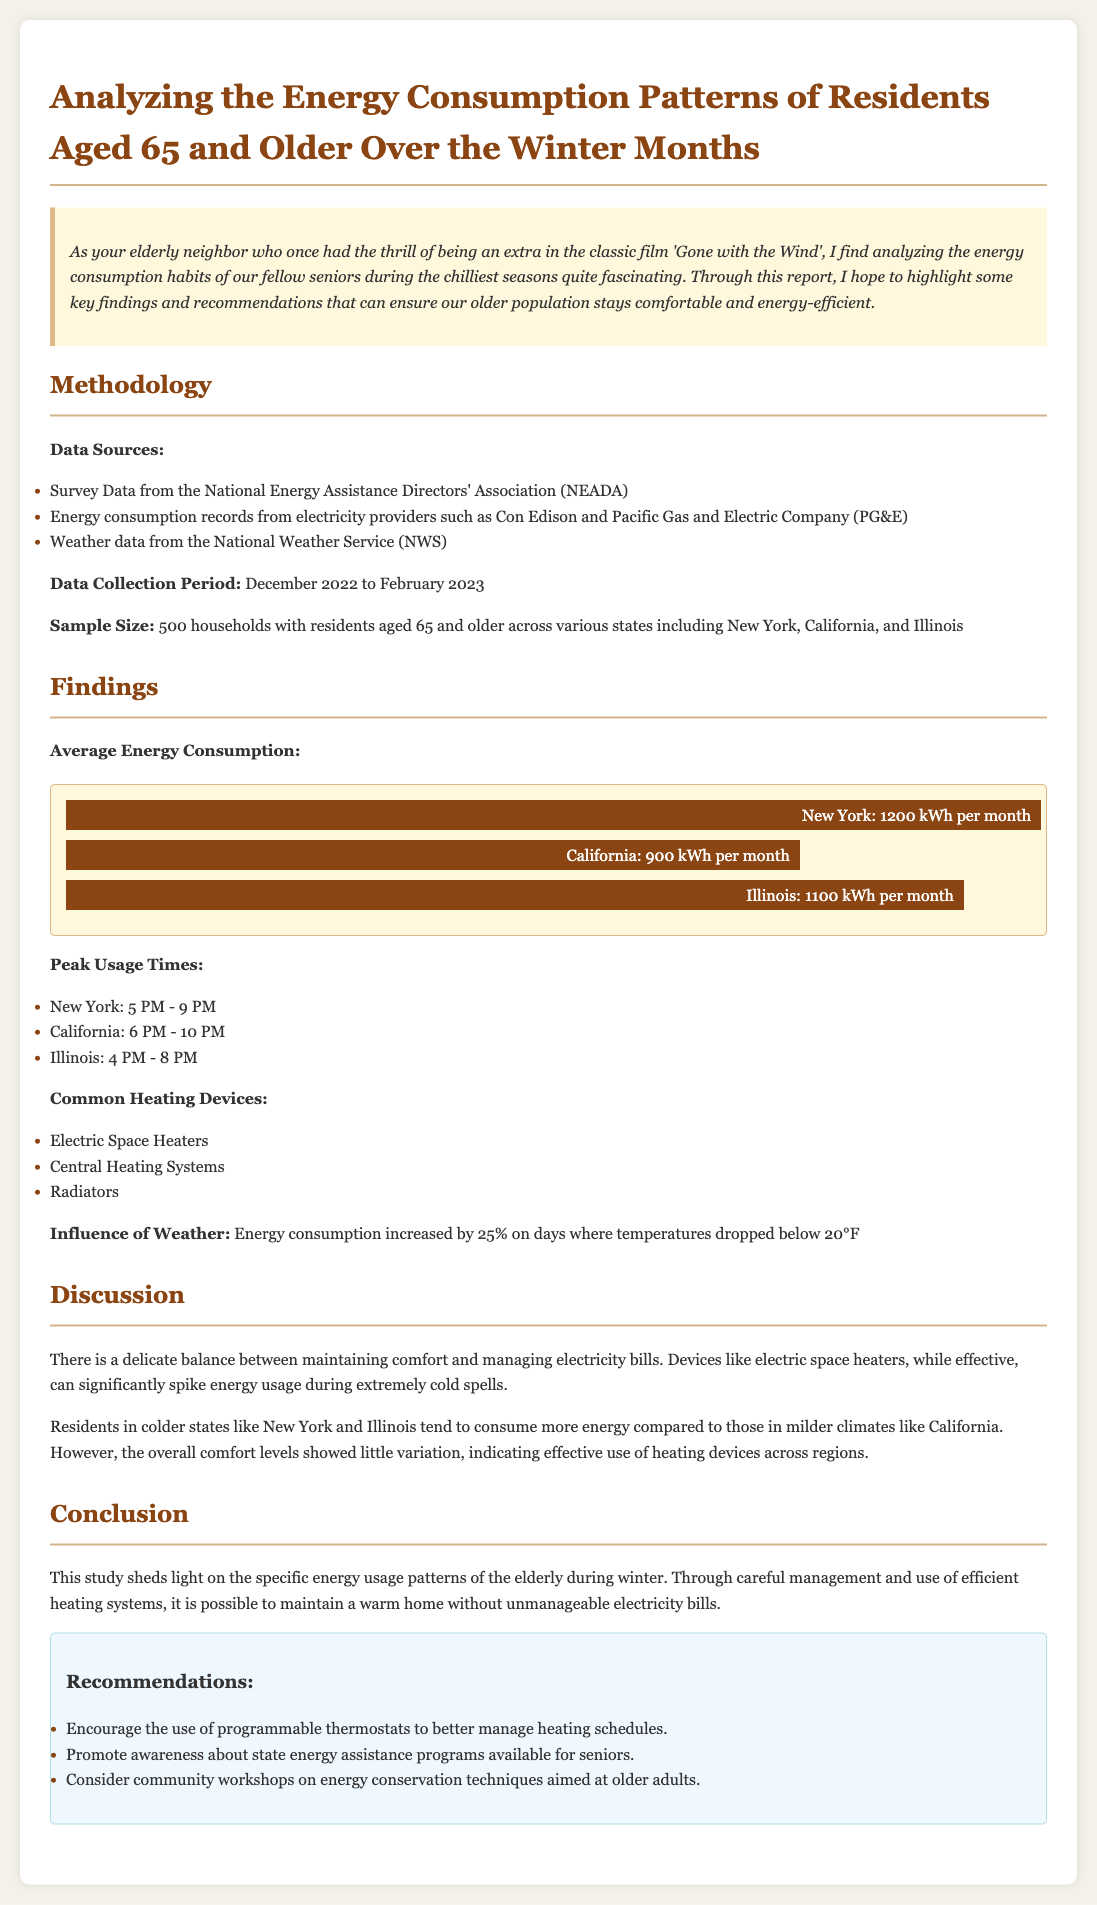What is the average energy consumption in New York? The average energy consumption in New York is specifically stated in the findings section of the document.
Answer: 1200 kWh per month What percentage did energy consumption increase in colder weather? The document highlights the influence of weather on energy consumption, specifically noting a percentage increase.
Answer: 25% What time frame represents peak usage in California? The peak usage times for California are listed in the findings section, regarding energy consumption.
Answer: 6 PM - 10 PM What is one common heating device mentioned? The findings section lists common heating devices used by the elderly residents during winter months.
Answer: Electric Space Heaters How many households were surveyed? The sample size is detailed in the methodology section of the document, providing specific information about the households included.
Answer: 500 households What is the data collection period? The document explicitly mentions the duration during which the data was collected, indicating the start and end months.
Answer: December 2022 to February 2023 What two states were compared to New York in terms of energy consumption? The document provides a comparison of energy consumption among different states, identifying specific states alongside New York.
Answer: California and Illinois What is one recommendation made in the conclusion? The recommendations section lists practical suggestions aimed at improving energy efficiency for seniors, found in the conclusion.
Answer: Encourage the use of programmable thermostats 